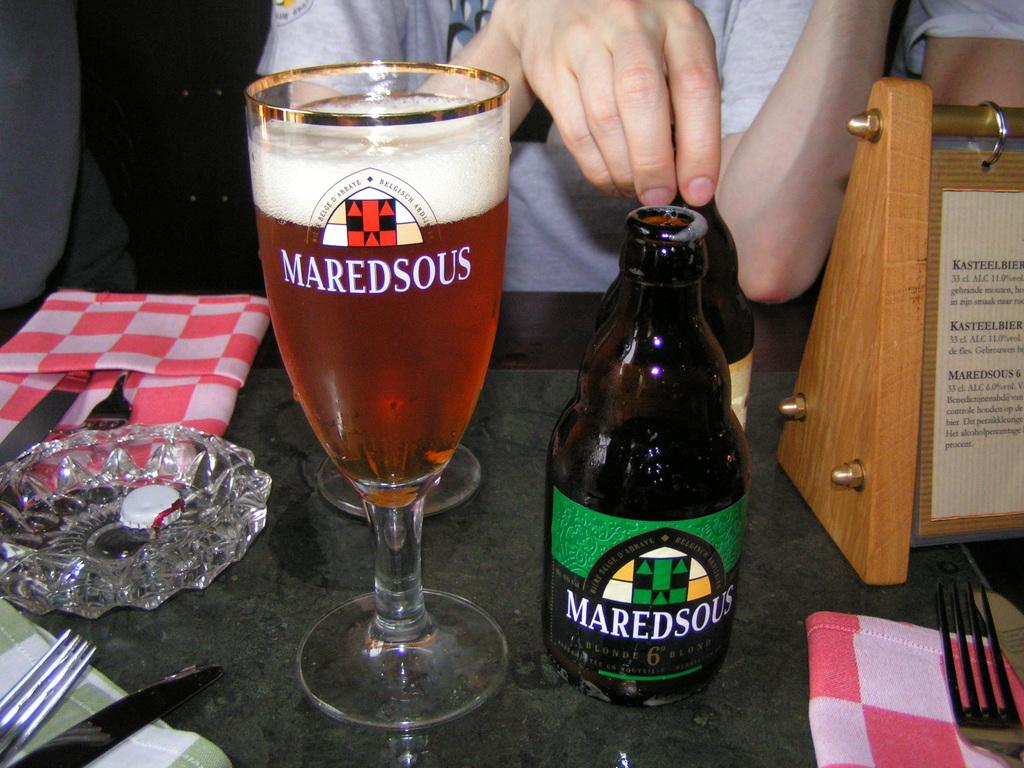<image>
Offer a succinct explanation of the picture presented. The brand name on the left glass cup is Maredsous 